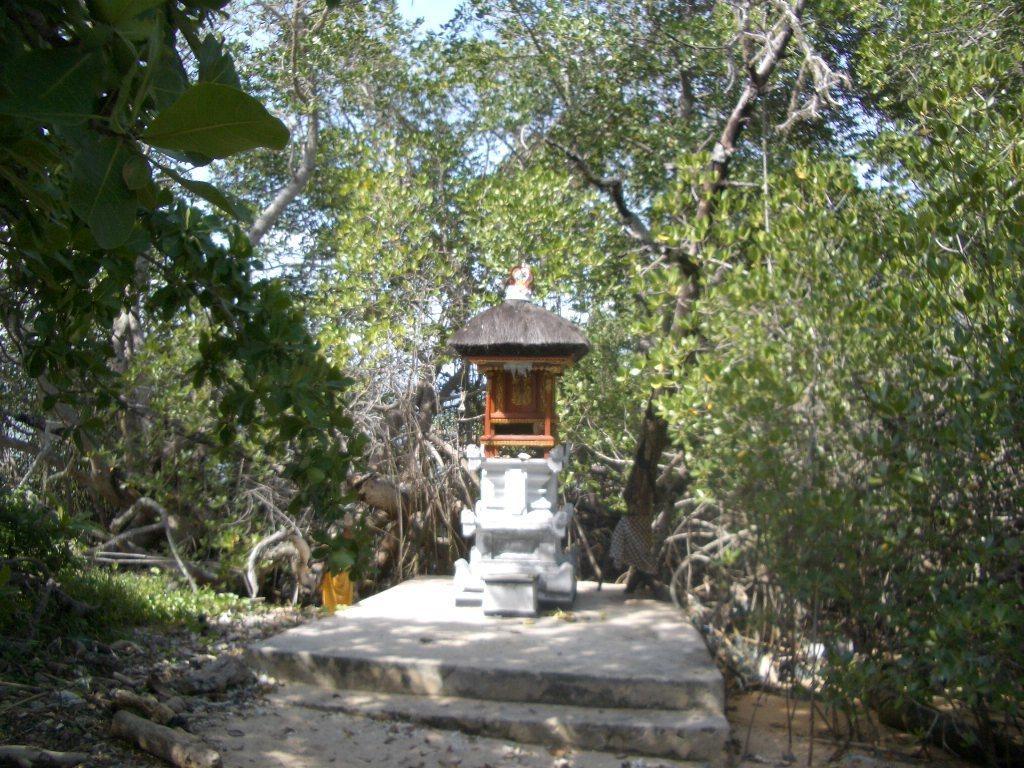Could you give a brief overview of what you see in this image? In the image I can see a temple like roof and around there are some plants and trees. 